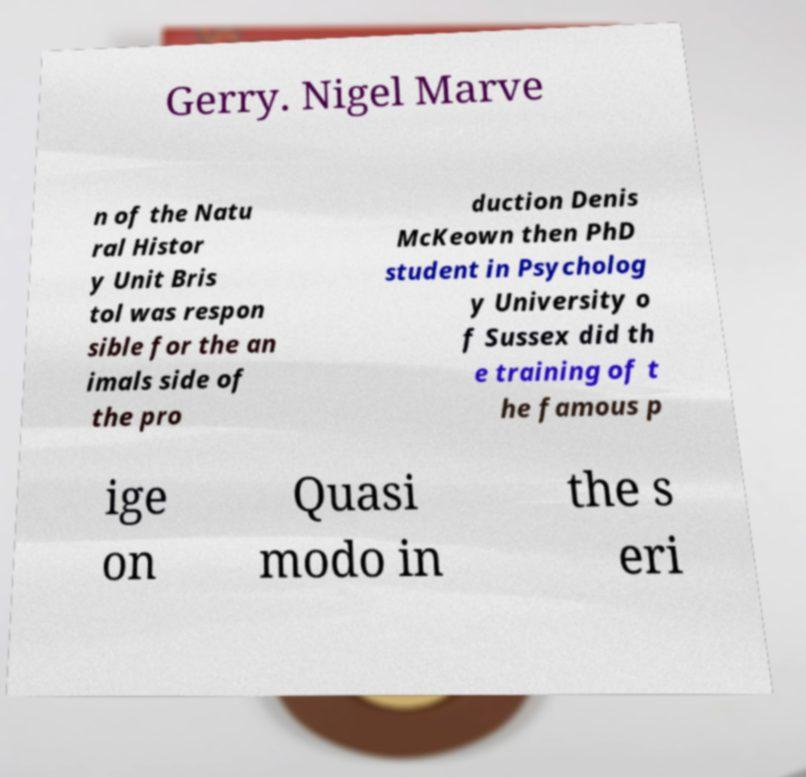What messages or text are displayed in this image? I need them in a readable, typed format. Gerry. Nigel Marve n of the Natu ral Histor y Unit Bris tol was respon sible for the an imals side of the pro duction Denis McKeown then PhD student in Psycholog y University o f Sussex did th e training of t he famous p ige on Quasi modo in the s eri 